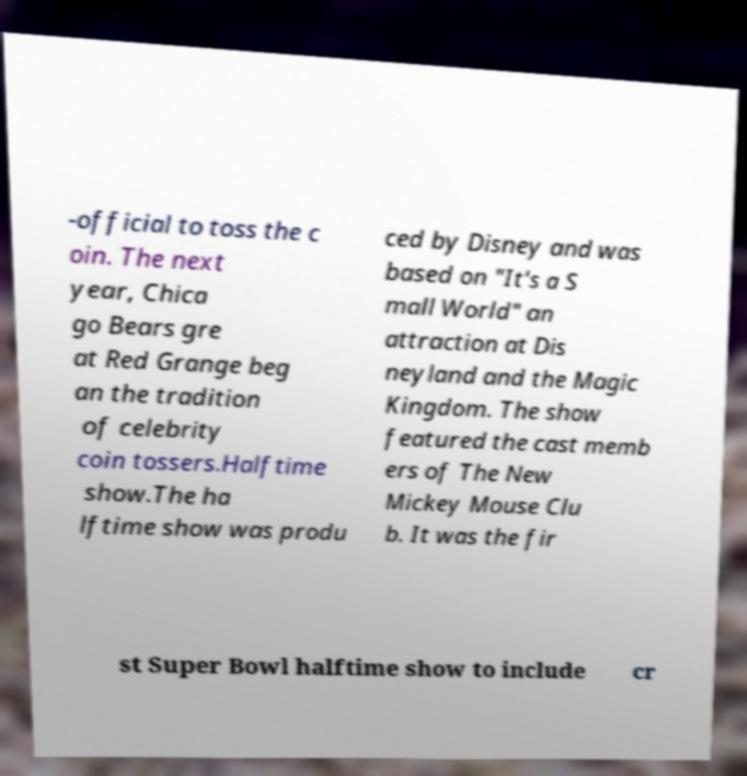Can you read and provide the text displayed in the image?This photo seems to have some interesting text. Can you extract and type it out for me? -official to toss the c oin. The next year, Chica go Bears gre at Red Grange beg an the tradition of celebrity coin tossers.Halftime show.The ha lftime show was produ ced by Disney and was based on "It's a S mall World" an attraction at Dis neyland and the Magic Kingdom. The show featured the cast memb ers of The New Mickey Mouse Clu b. It was the fir st Super Bowl halftime show to include cr 